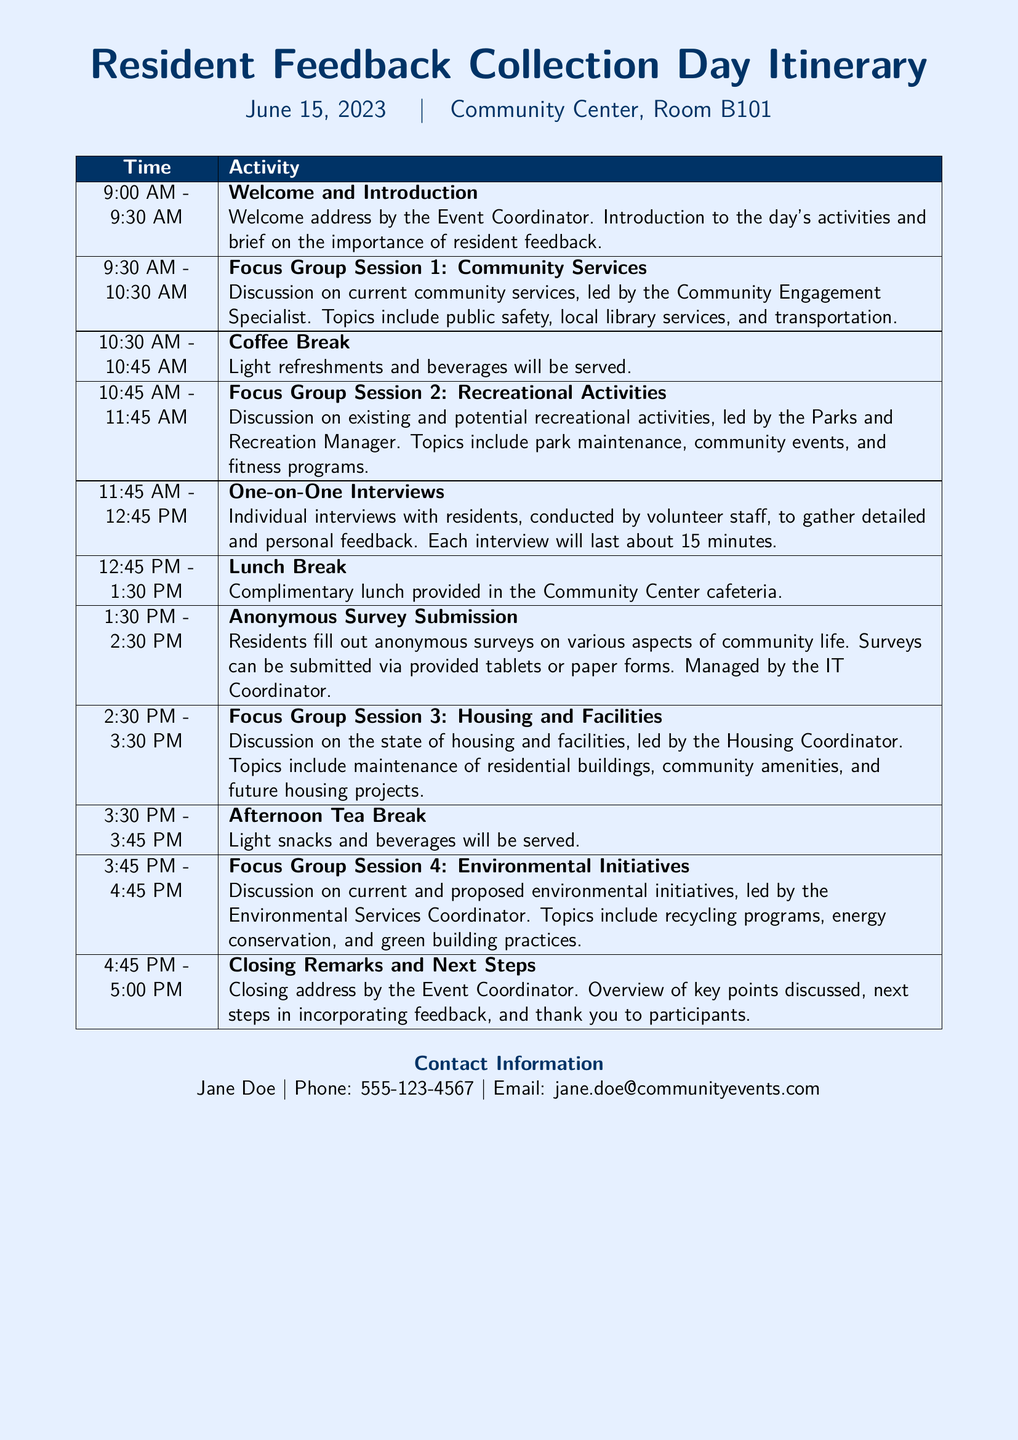What is the date of the event? The date of the event is provided in the document header.
Answer: June 15, 2023 What time does the Welcome and Introduction start? The start time is found in the itinerary table under the first activity.
Answer: 9:00 AM Who leads the Focus Group Session on Community Services? The leader of the session is mentioned in the activity description.
Answer: Community Engagement Specialist How long is each One-on-One Interview scheduled to last? The duration for the interviews is stated in the activity description.
Answer: 15 minutes What is provided during the Lunch Break? The details of the Lunch Break activity are specified in the itinerary.
Answer: Complimentary lunch What is the duration of Focus Group Session 3? The duration is inferred from the start and end times listed in the itinerary.
Answer: 1 hour What is the final activity listed in the itinerary? The last item in the itinerary corresponds to the closing of the event.
Answer: Closing Remarks and Next Steps How many focus group sessions are scheduled? The count of focus group sessions can be determined from the activities listed.
Answer: Four What color is mentioned for the page background? The color of the page background is described at the beginning of the document.
Answer: Light blue 